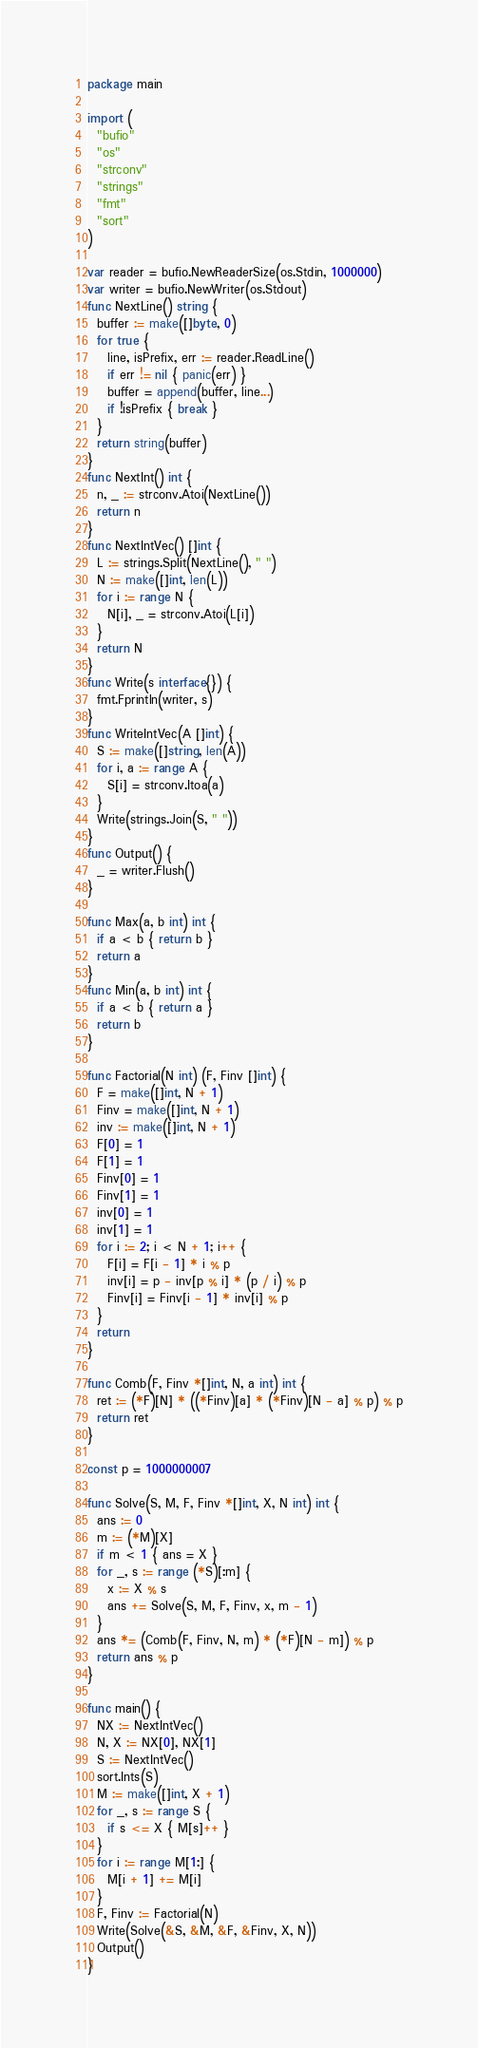<code> <loc_0><loc_0><loc_500><loc_500><_Go_>package main

import (
  "bufio"
  "os"
  "strconv"
  "strings"
  "fmt"
  "sort"
)

var reader = bufio.NewReaderSize(os.Stdin, 1000000)
var writer = bufio.NewWriter(os.Stdout)
func NextLine() string {
  buffer := make([]byte, 0)
  for true {
    line, isPrefix, err := reader.ReadLine()
    if err != nil { panic(err) }
    buffer = append(buffer, line...)
    if !isPrefix { break }
  }
  return string(buffer)
}
func NextInt() int {
  n, _ := strconv.Atoi(NextLine())
  return n
}
func NextIntVec() []int {
  L := strings.Split(NextLine(), " ")
  N := make([]int, len(L))
  for i := range N {
    N[i], _ = strconv.Atoi(L[i])
  }
  return N
}
func Write(s interface{}) {
  fmt.Fprintln(writer, s)
}
func WriteIntVec(A []int) {
  S := make([]string, len(A))
  for i, a := range A {
    S[i] = strconv.Itoa(a)
  }
  Write(strings.Join(S, " "))
}
func Output() {
  _ = writer.Flush()
}

func Max(a, b int) int {
  if a < b { return b }
  return a
}
func Min(a, b int) int {
  if a < b { return a }
  return b
}

func Factorial(N int) (F, Finv []int) {
  F = make([]int, N + 1)
  Finv = make([]int, N + 1)
  inv := make([]int, N + 1)
  F[0] = 1
  F[1] = 1
  Finv[0] = 1
  Finv[1] = 1
  inv[0] = 1
  inv[1] = 1
  for i := 2; i < N + 1; i++ {
    F[i] = F[i - 1] * i % p
    inv[i] = p - inv[p % i] * (p / i) % p
    Finv[i] = Finv[i - 1] * inv[i] % p
  }
  return
}

func Comb(F, Finv *[]int, N, a int) int {
  ret := (*F)[N] * ((*Finv)[a] * (*Finv)[N - a] % p) % p
  return ret
}

const p = 1000000007

func Solve(S, M, F, Finv *[]int, X, N int) int {
  ans := 0
  m := (*M)[X]
  if m < 1 { ans = X }
  for _, s := range (*S)[:m] {
    x := X % s
    ans += Solve(S, M, F, Finv, x, m - 1)
  }
  ans *= (Comb(F, Finv, N, m) * (*F)[N - m]) % p
  return ans % p
}

func main() {
  NX := NextIntVec()
  N, X := NX[0], NX[1]
  S := NextIntVec()
  sort.Ints(S)
  M := make([]int, X + 1)
  for _, s := range S {
    if s <= X { M[s]++ }
  }
  for i := range M[1:] {
    M[i + 1] += M[i]
  }
  F, Finv := Factorial(N)
  Write(Solve(&S, &M, &F, &Finv, X, N))
  Output()
}</code> 